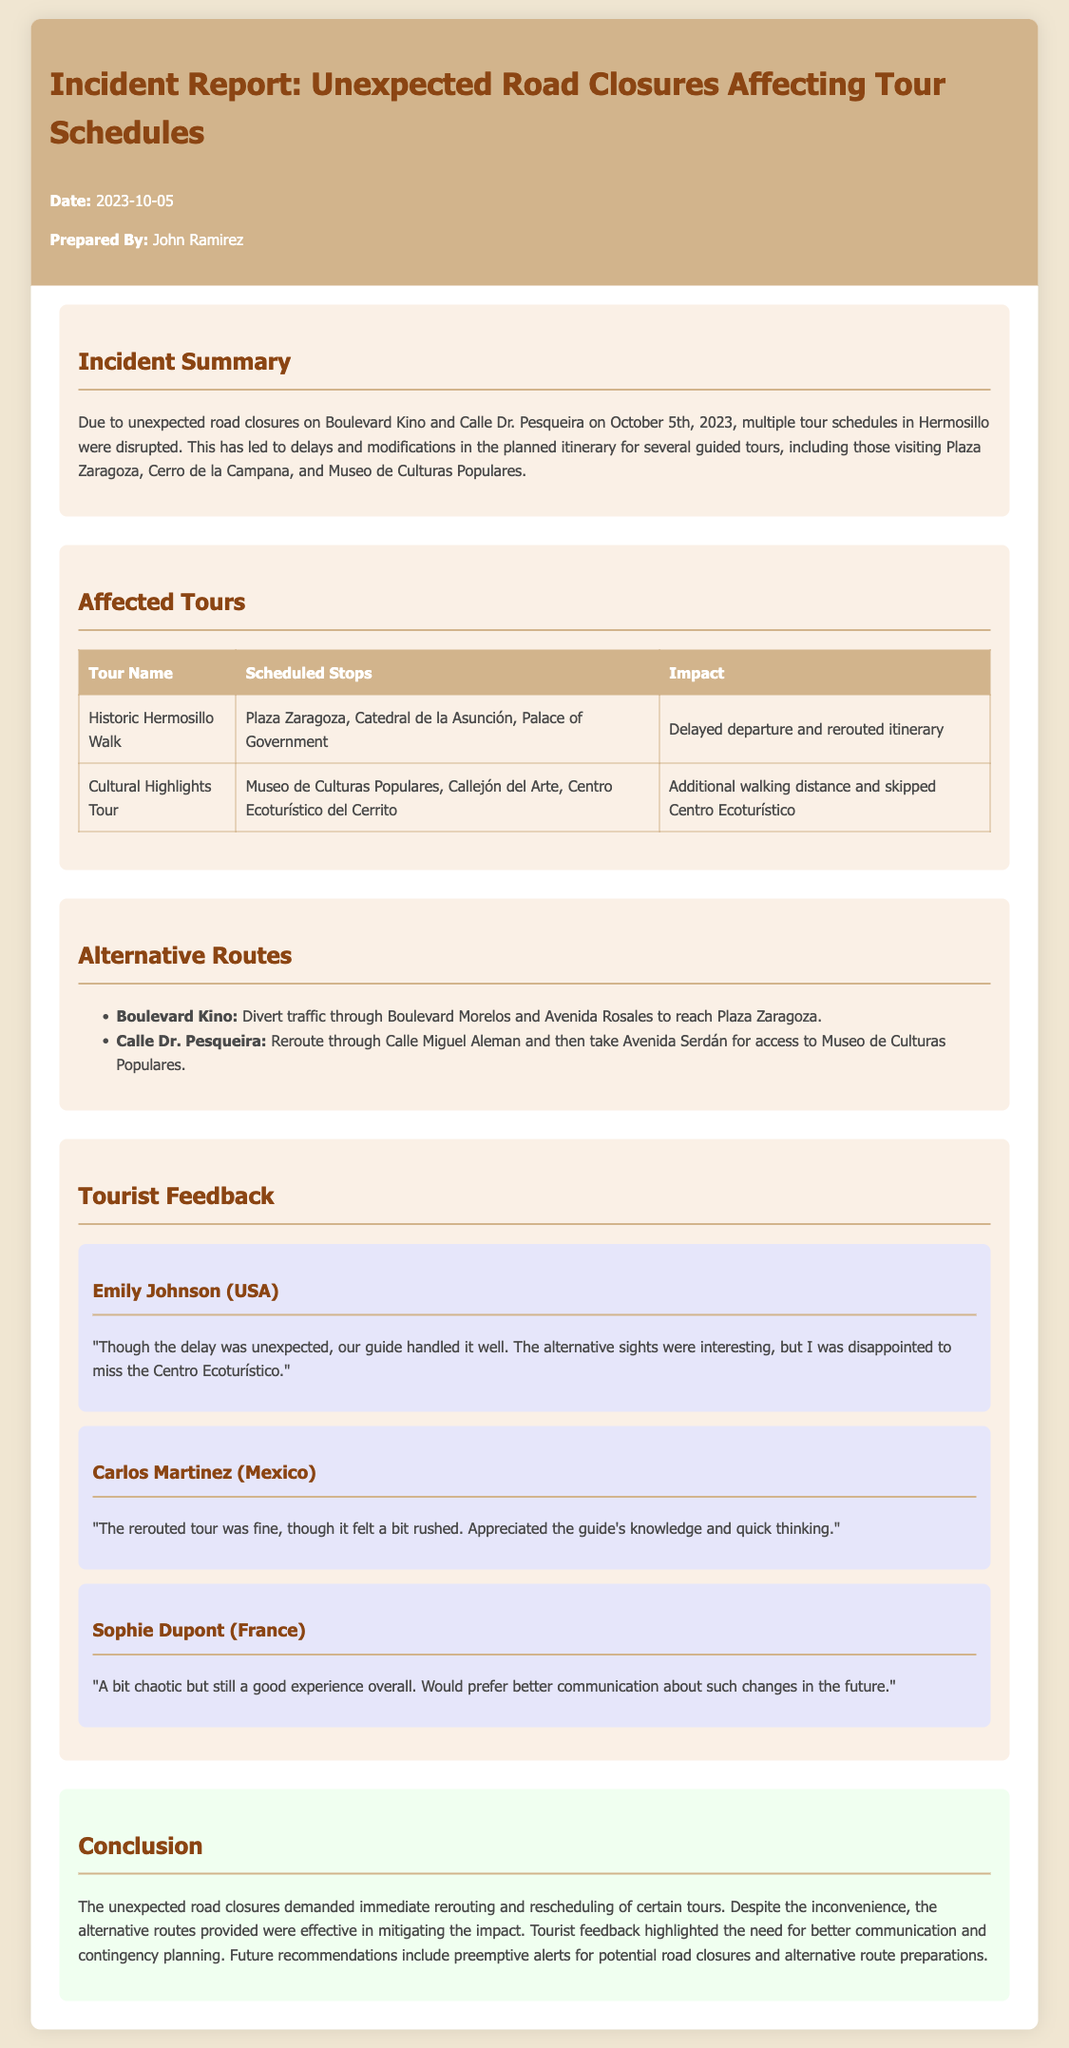What caused the tour schedule disruptions? The disruptions were caused by unexpected road closures on Boulevard Kino and Calle Dr. Pesqueira.
Answer: Unexpected road closures What is the date of the incident report? The date of the incident report is stated in the document.
Answer: 2023-10-05 Who prepared the incident report? The preparer's name is mentioned in the report.
Answer: John Ramirez Which tour had delayed departure and a rerouted itinerary? The affected tour with a delayed departure is specified in the document.
Answer: Historic Hermosillo Walk What was one alternative route suggested for Boulevard Kino? The report provides an alternative route for Boulevard Kino, which is described in the document.
Answer: Boulevard Morelos and Avenida Rosales Which tourist expressed disappointment about missing a site? The feedback section includes tourist comments, one of which mentions disappointment about a site.
Answer: Emily Johnson What type of feedback did Carlos Martinez provide? The nature of the feedback from Carlos Martinez is specified in his comment.
Answer: Fine but felt rushed What is one recommendation for future incidents mentioned in the report? The conclusions section offers suggestions for future improvements related to road closures.
Answer: Preemptive alerts for potential road closures 